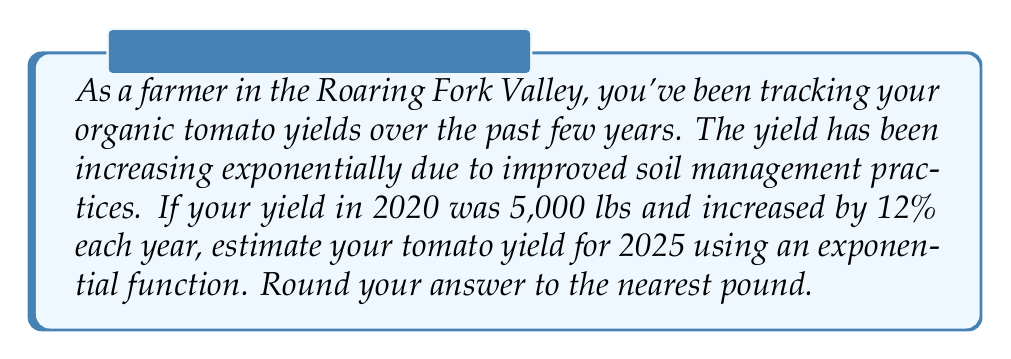Teach me how to tackle this problem. Let's approach this step-by-step:

1) First, we need to identify the components of our exponential function:
   - Initial value (a) = 5,000 lbs (yield in 2020)
   - Growth rate (r) = 12% = 0.12
   - Time (t) = 5 years (from 2020 to 2025)

2) The exponential function for growth is:
   $$ Y = a(1 + r)^t $$
   Where Y is the final amount, a is the initial amount, r is the growth rate, and t is the time.

3) Let's plug in our values:
   $$ Y = 5000(1 + 0.12)^5 $$

4) Simplify inside the parentheses:
   $$ Y = 5000(1.12)^5 $$

5) Calculate $(1.12)^5$:
   $$ (1.12)^5 = 1.7623416 $$

6) Multiply by 5000:
   $$ Y = 5000 * 1.7623416 = 8811.708 $$

7) Rounding to the nearest pound:
   $$ Y ≈ 8,812 \text{ lbs} $$

Therefore, the estimated tomato yield for 2025 is approximately 8,812 lbs.
Answer: 8,812 lbs 